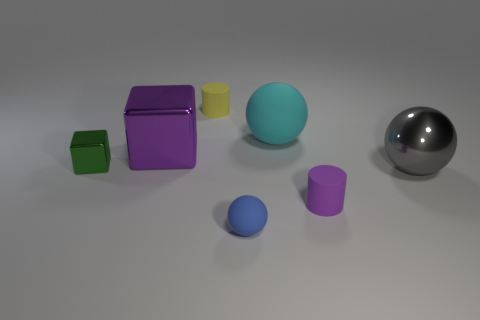Add 3 big purple objects. How many objects exist? 10 Subtract all cubes. How many objects are left? 5 Subtract 0 green spheres. How many objects are left? 7 Subtract all small blue cylinders. Subtract all tiny blue balls. How many objects are left? 6 Add 3 green metallic blocks. How many green metallic blocks are left? 4 Add 1 purple rubber things. How many purple rubber things exist? 2 